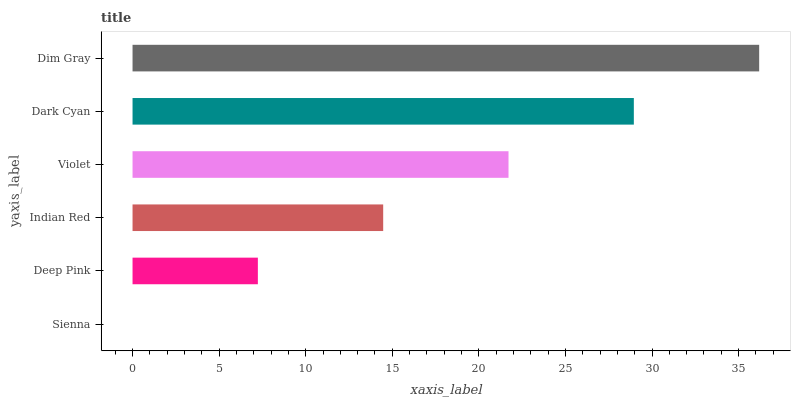Is Sienna the minimum?
Answer yes or no. Yes. Is Dim Gray the maximum?
Answer yes or no. Yes. Is Deep Pink the minimum?
Answer yes or no. No. Is Deep Pink the maximum?
Answer yes or no. No. Is Deep Pink greater than Sienna?
Answer yes or no. Yes. Is Sienna less than Deep Pink?
Answer yes or no. Yes. Is Sienna greater than Deep Pink?
Answer yes or no. No. Is Deep Pink less than Sienna?
Answer yes or no. No. Is Violet the high median?
Answer yes or no. Yes. Is Indian Red the low median?
Answer yes or no. Yes. Is Dim Gray the high median?
Answer yes or no. No. Is Dark Cyan the low median?
Answer yes or no. No. 